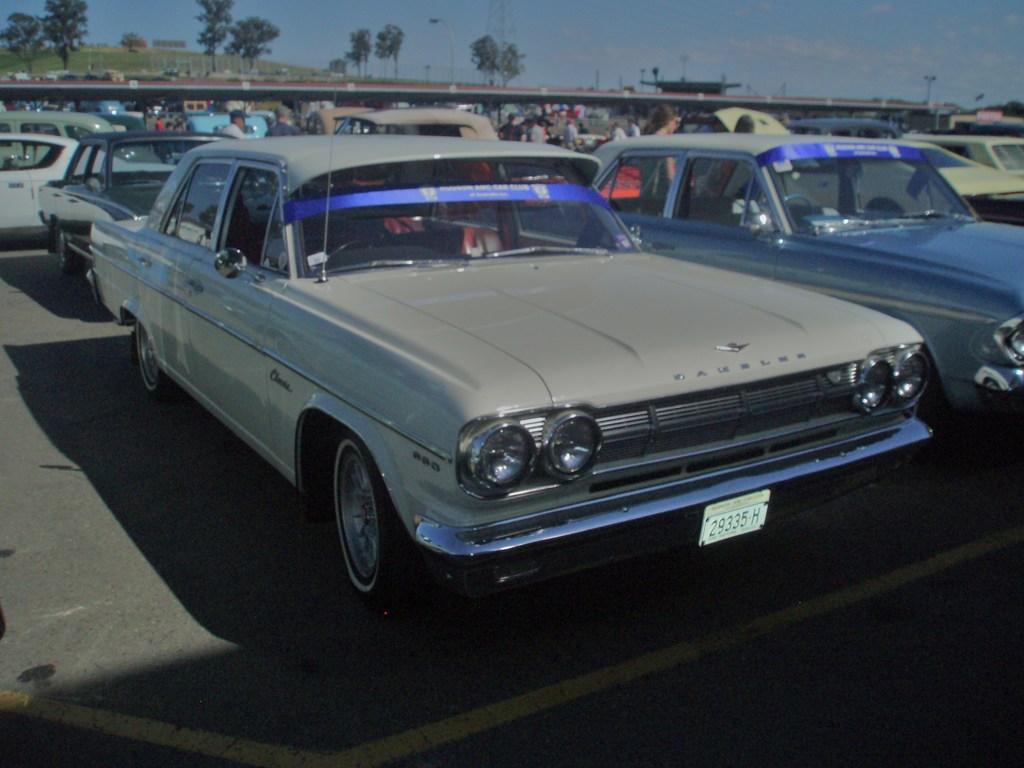What is their license plate number?
Make the answer very short. 29335 h. 